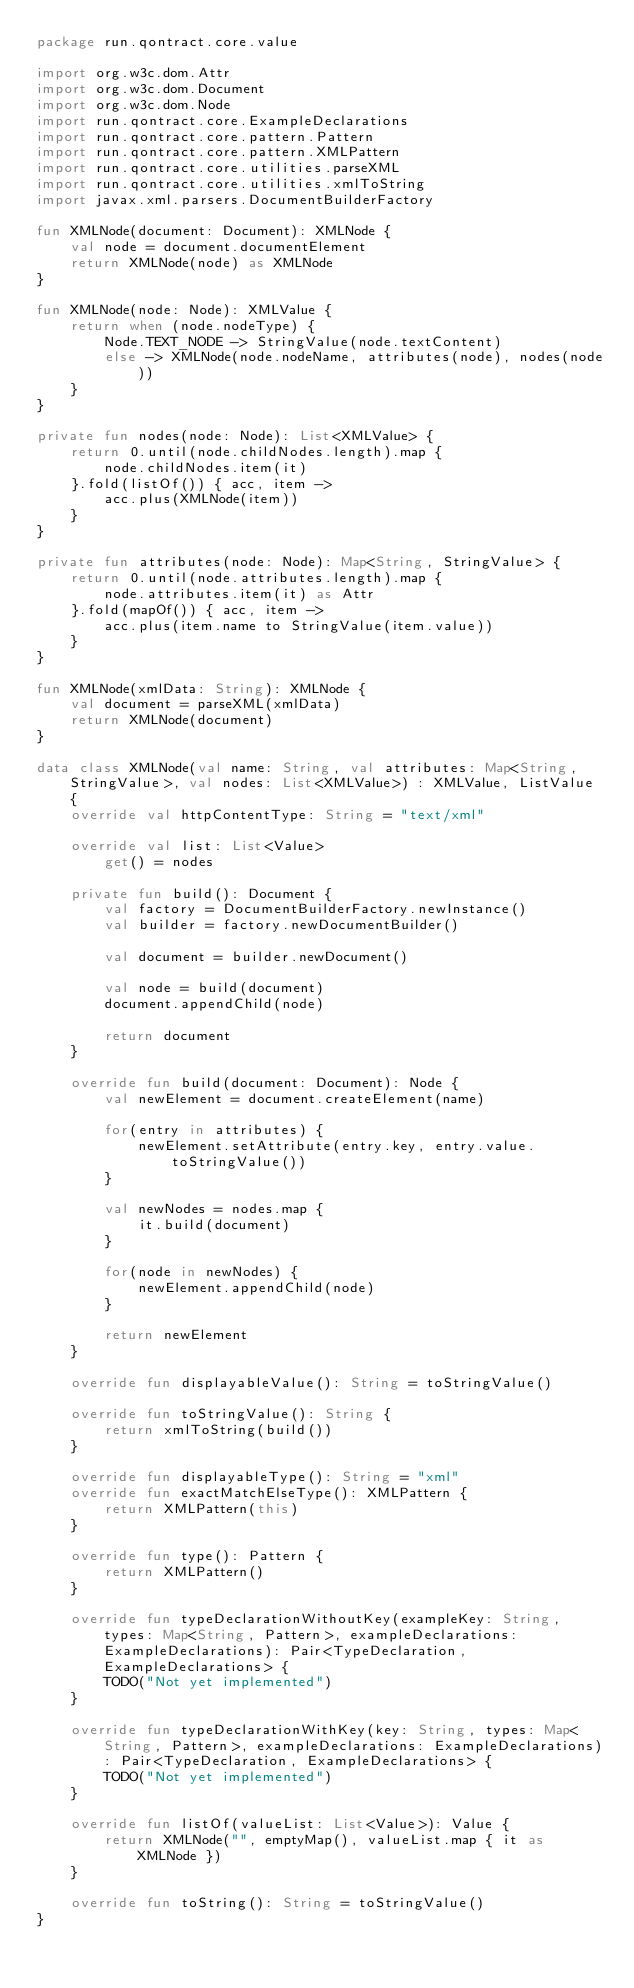<code> <loc_0><loc_0><loc_500><loc_500><_Kotlin_>package run.qontract.core.value

import org.w3c.dom.Attr
import org.w3c.dom.Document
import org.w3c.dom.Node
import run.qontract.core.ExampleDeclarations
import run.qontract.core.pattern.Pattern
import run.qontract.core.pattern.XMLPattern
import run.qontract.core.utilities.parseXML
import run.qontract.core.utilities.xmlToString
import javax.xml.parsers.DocumentBuilderFactory

fun XMLNode(document: Document): XMLNode {
    val node = document.documentElement
    return XMLNode(node) as XMLNode
}

fun XMLNode(node: Node): XMLValue {
    return when (node.nodeType) {
        Node.TEXT_NODE -> StringValue(node.textContent)
        else -> XMLNode(node.nodeName, attributes(node), nodes(node))
    }
}

private fun nodes(node: Node): List<XMLValue> {
    return 0.until(node.childNodes.length).map {
        node.childNodes.item(it)
    }.fold(listOf()) { acc, item ->
        acc.plus(XMLNode(item))
    }
}

private fun attributes(node: Node): Map<String, StringValue> {
    return 0.until(node.attributes.length).map {
        node.attributes.item(it) as Attr
    }.fold(mapOf()) { acc, item ->
        acc.plus(item.name to StringValue(item.value))
    }
}

fun XMLNode(xmlData: String): XMLNode {
    val document = parseXML(xmlData)
    return XMLNode(document)
}

data class XMLNode(val name: String, val attributes: Map<String, StringValue>, val nodes: List<XMLValue>) : XMLValue, ListValue {
    override val httpContentType: String = "text/xml"

    override val list: List<Value>
        get() = nodes

    private fun build(): Document {
        val factory = DocumentBuilderFactory.newInstance()
        val builder = factory.newDocumentBuilder()

        val document = builder.newDocument()

        val node = build(document)
        document.appendChild(node)

        return document
    }

    override fun build(document: Document): Node {
        val newElement = document.createElement(name)

        for(entry in attributes) {
            newElement.setAttribute(entry.key, entry.value.toStringValue())
        }

        val newNodes = nodes.map {
            it.build(document)
        }

        for(node in newNodes) {
            newElement.appendChild(node)
        }

        return newElement
    }

    override fun displayableValue(): String = toStringValue()

    override fun toStringValue(): String {
        return xmlToString(build())
    }

    override fun displayableType(): String = "xml"
    override fun exactMatchElseType(): XMLPattern {
        return XMLPattern(this)
    }

    override fun type(): Pattern {
        return XMLPattern()
    }

    override fun typeDeclarationWithoutKey(exampleKey: String, types: Map<String, Pattern>, exampleDeclarations: ExampleDeclarations): Pair<TypeDeclaration, ExampleDeclarations> {
        TODO("Not yet implemented")
    }

    override fun typeDeclarationWithKey(key: String, types: Map<String, Pattern>, exampleDeclarations: ExampleDeclarations): Pair<TypeDeclaration, ExampleDeclarations> {
        TODO("Not yet implemented")
    }

    override fun listOf(valueList: List<Value>): Value {
        return XMLNode("", emptyMap(), valueList.map { it as XMLNode })
    }

    override fun toString(): String = toStringValue()
}</code> 